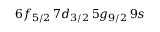Convert formula to latex. <formula><loc_0><loc_0><loc_500><loc_500>6 f _ { 5 / 2 } \, 7 d _ { 3 / 2 } \, 5 g _ { 9 / 2 } \, 9 s</formula> 